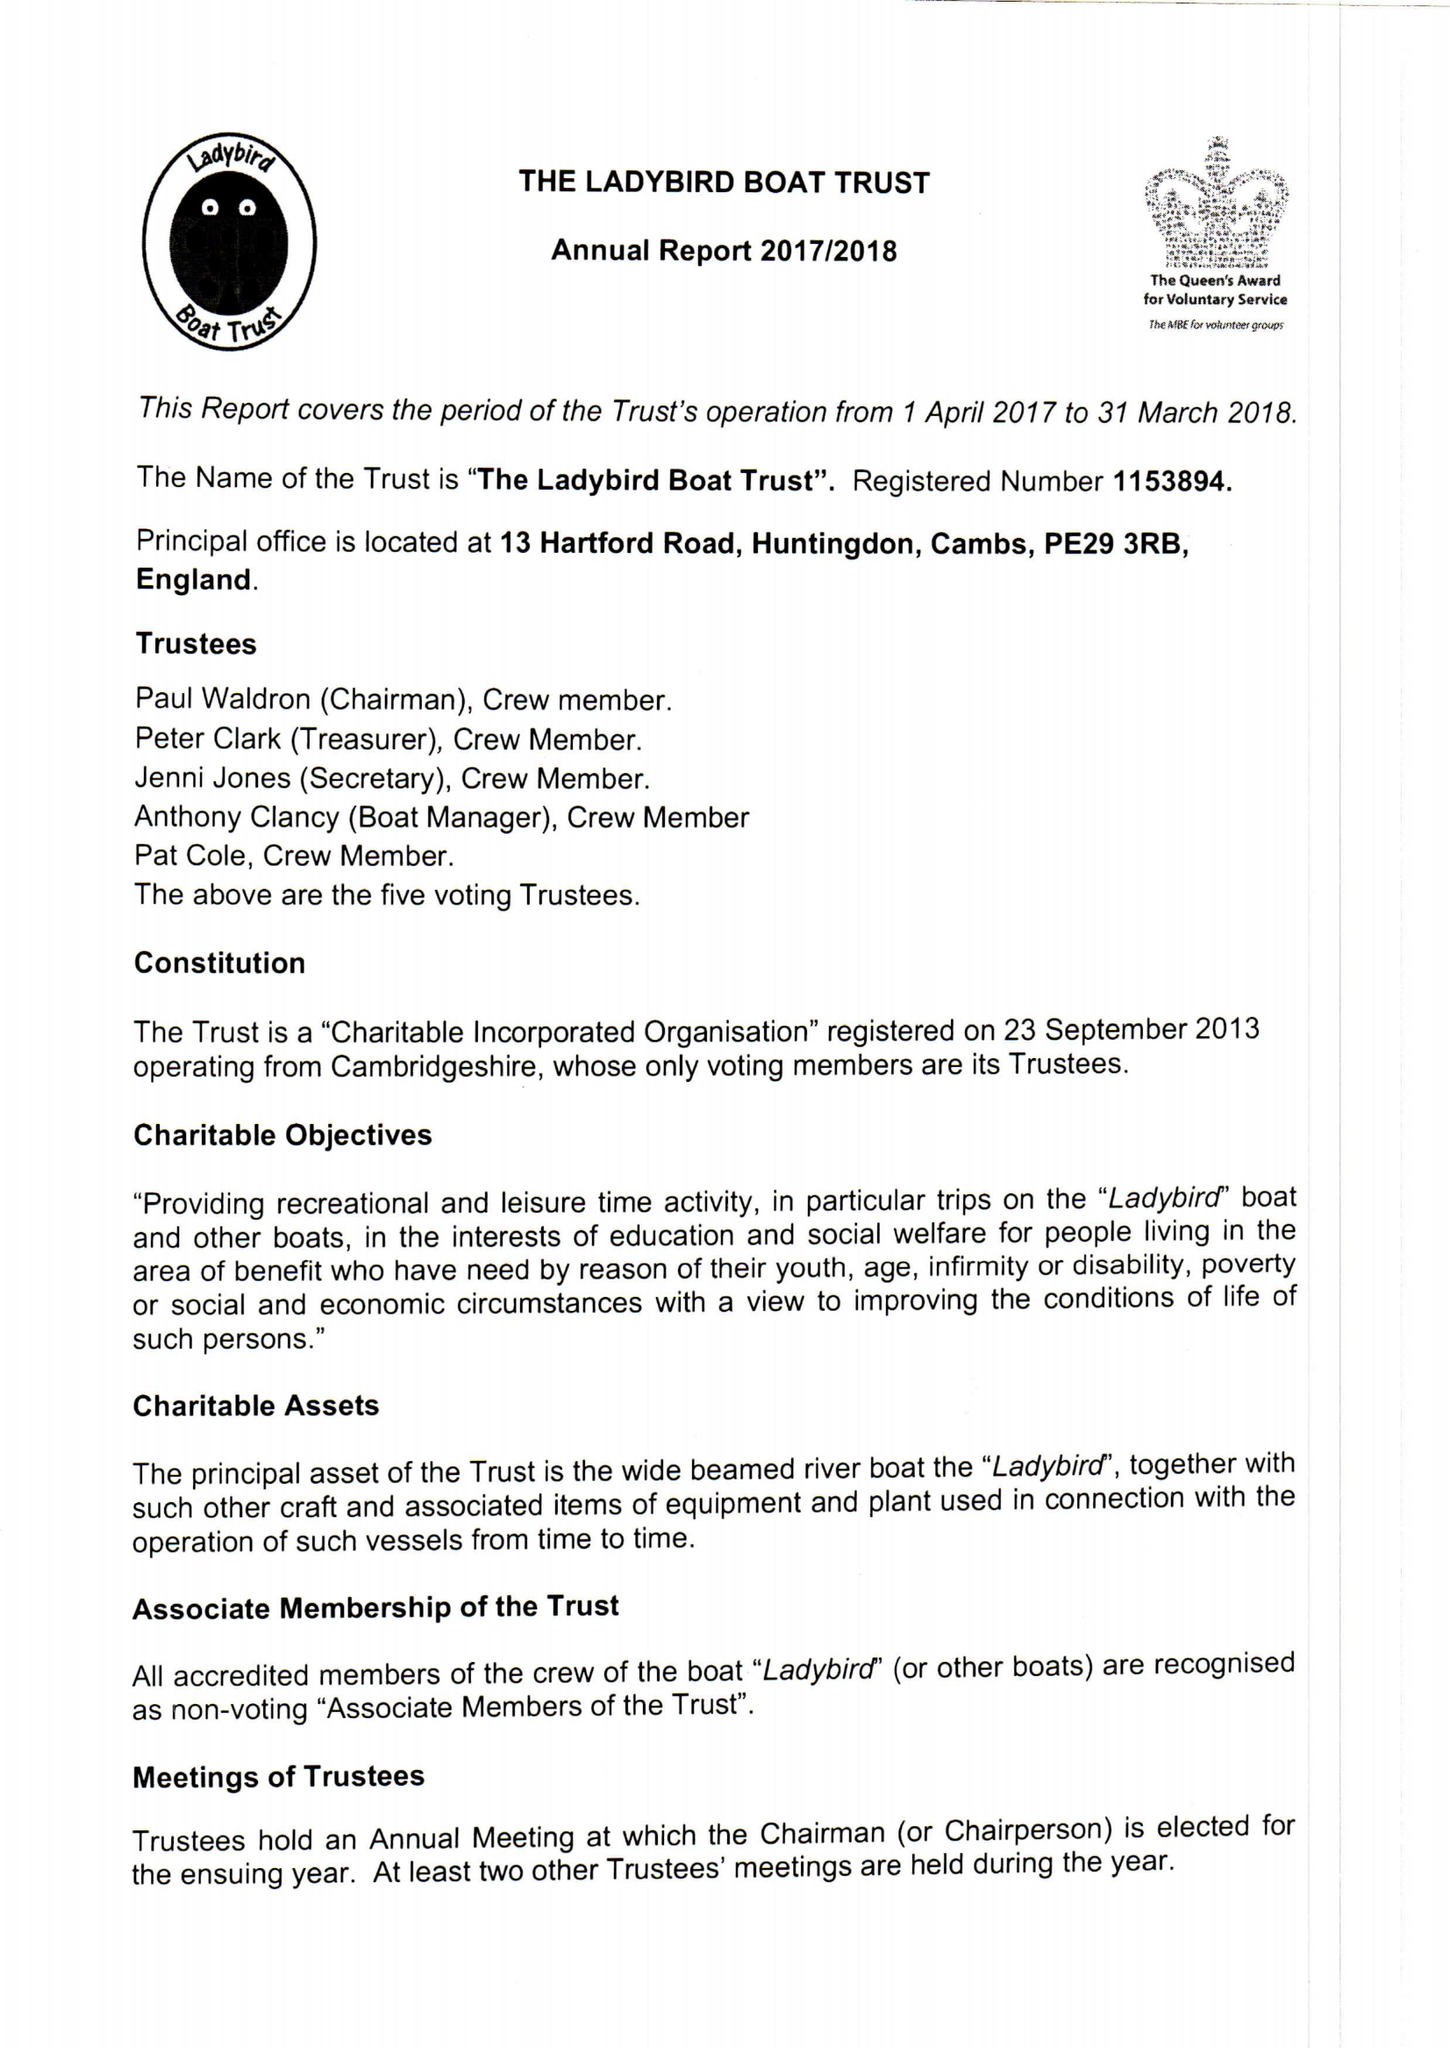What is the value for the charity_name?
Answer the question using a single word or phrase. The Ladybird Boat Trust 